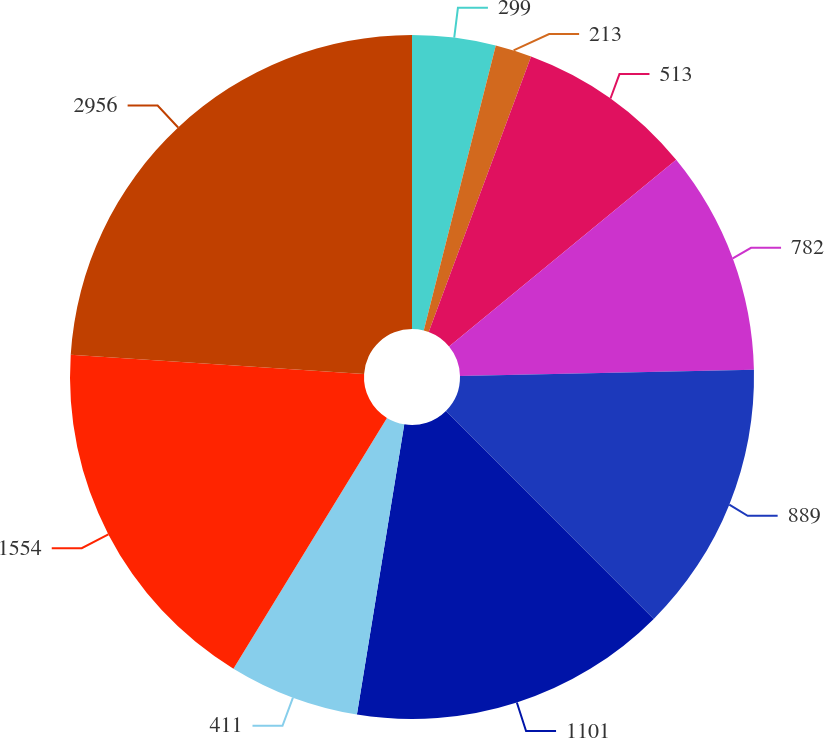<chart> <loc_0><loc_0><loc_500><loc_500><pie_chart><fcel>299<fcel>213<fcel>513<fcel>782<fcel>889<fcel>1101<fcel>411<fcel>1554<fcel>2956<nl><fcel>3.94%<fcel>1.72%<fcel>8.39%<fcel>10.62%<fcel>12.84%<fcel>15.07%<fcel>6.17%<fcel>17.29%<fcel>23.97%<nl></chart> 